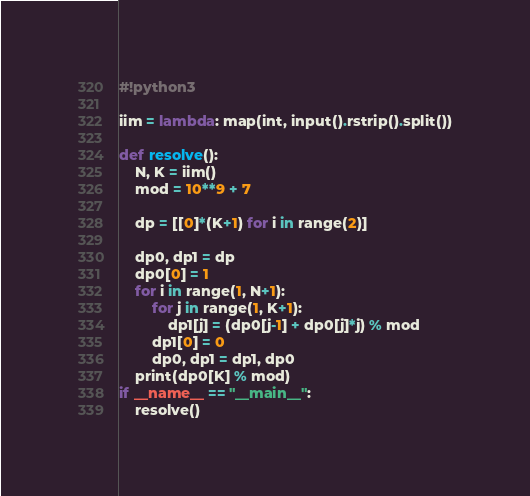<code> <loc_0><loc_0><loc_500><loc_500><_Python_>#!python3

iim = lambda: map(int, input().rstrip().split())

def resolve():
    N, K = iim()
    mod = 10**9 + 7

    dp = [[0]*(K+1) for i in range(2)]

    dp0, dp1 = dp
    dp0[0] = 1
    for i in range(1, N+1):
        for j in range(1, K+1):
            dp1[j] = (dp0[j-1] + dp0[j]*j) % mod
        dp1[0] = 0
        dp0, dp1 = dp1, dp0
    print(dp0[K] % mod)
if __name__ == "__main__":
    resolve()

</code> 